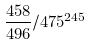<formula> <loc_0><loc_0><loc_500><loc_500>\frac { 4 5 8 } { 4 9 6 } / 4 7 5 ^ { 2 4 5 }</formula> 